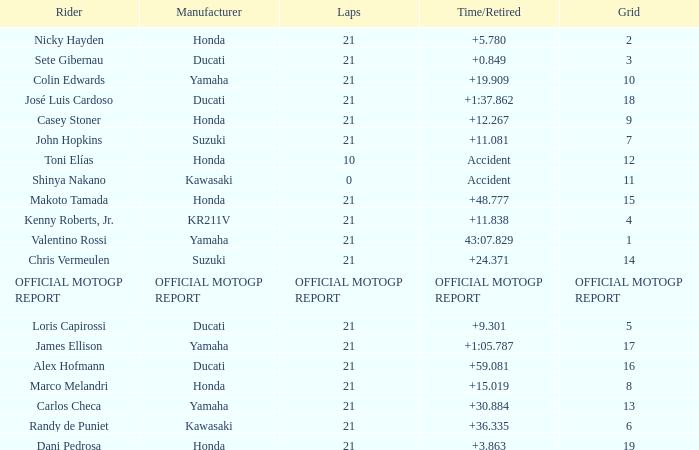What is the time/retired for the rider with the manufacturuer yamaha, grod of 1 and 21 total laps? 43:07.829. 